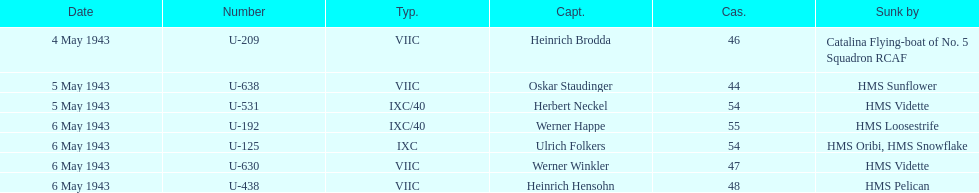What is the only vessel to sink multiple u-boats? HMS Vidette. 